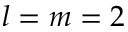<formula> <loc_0><loc_0><loc_500><loc_500>l = m = 2</formula> 